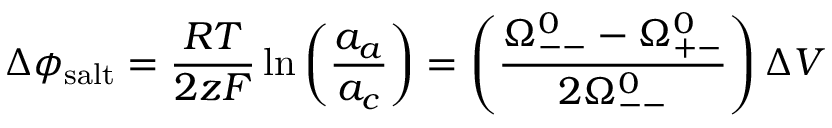Convert formula to latex. <formula><loc_0><loc_0><loc_500><loc_500>\Delta \phi _ { s a l t } = \frac { R T } { 2 z F } \ln \left ( \frac { a _ { a } } { a _ { c } } \right ) = \left ( \frac { \Omega _ { - - } ^ { 0 } - \Omega _ { + - } ^ { 0 } } { 2 \Omega _ { - - } ^ { 0 } } \right ) \Delta V</formula> 